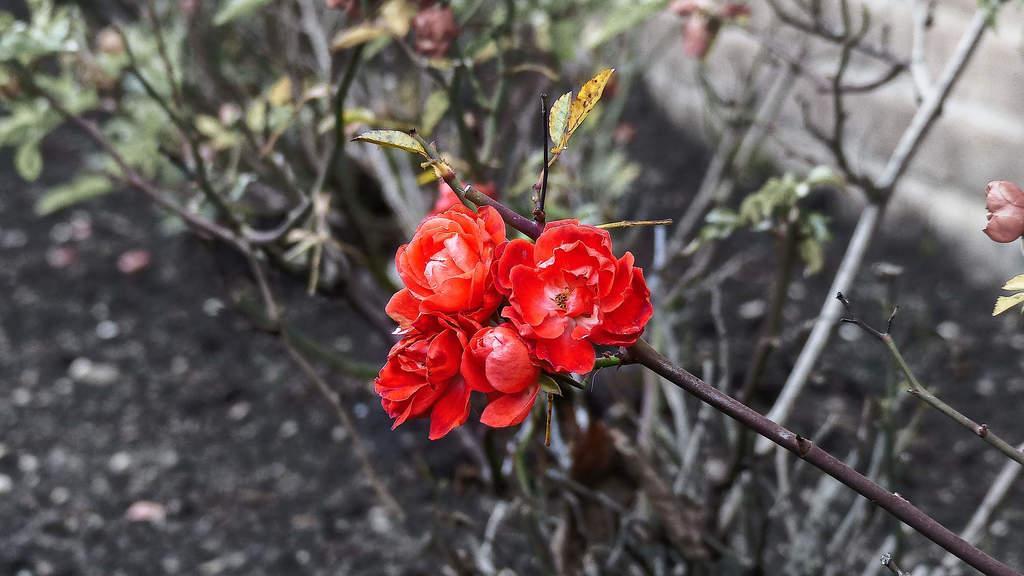How would you summarize this image in a sentence or two? This picture is clicked outside. In the center we can see the flowers and leaves of a plant. In the background we can see the plants, leaves, flowers and some other objects. 